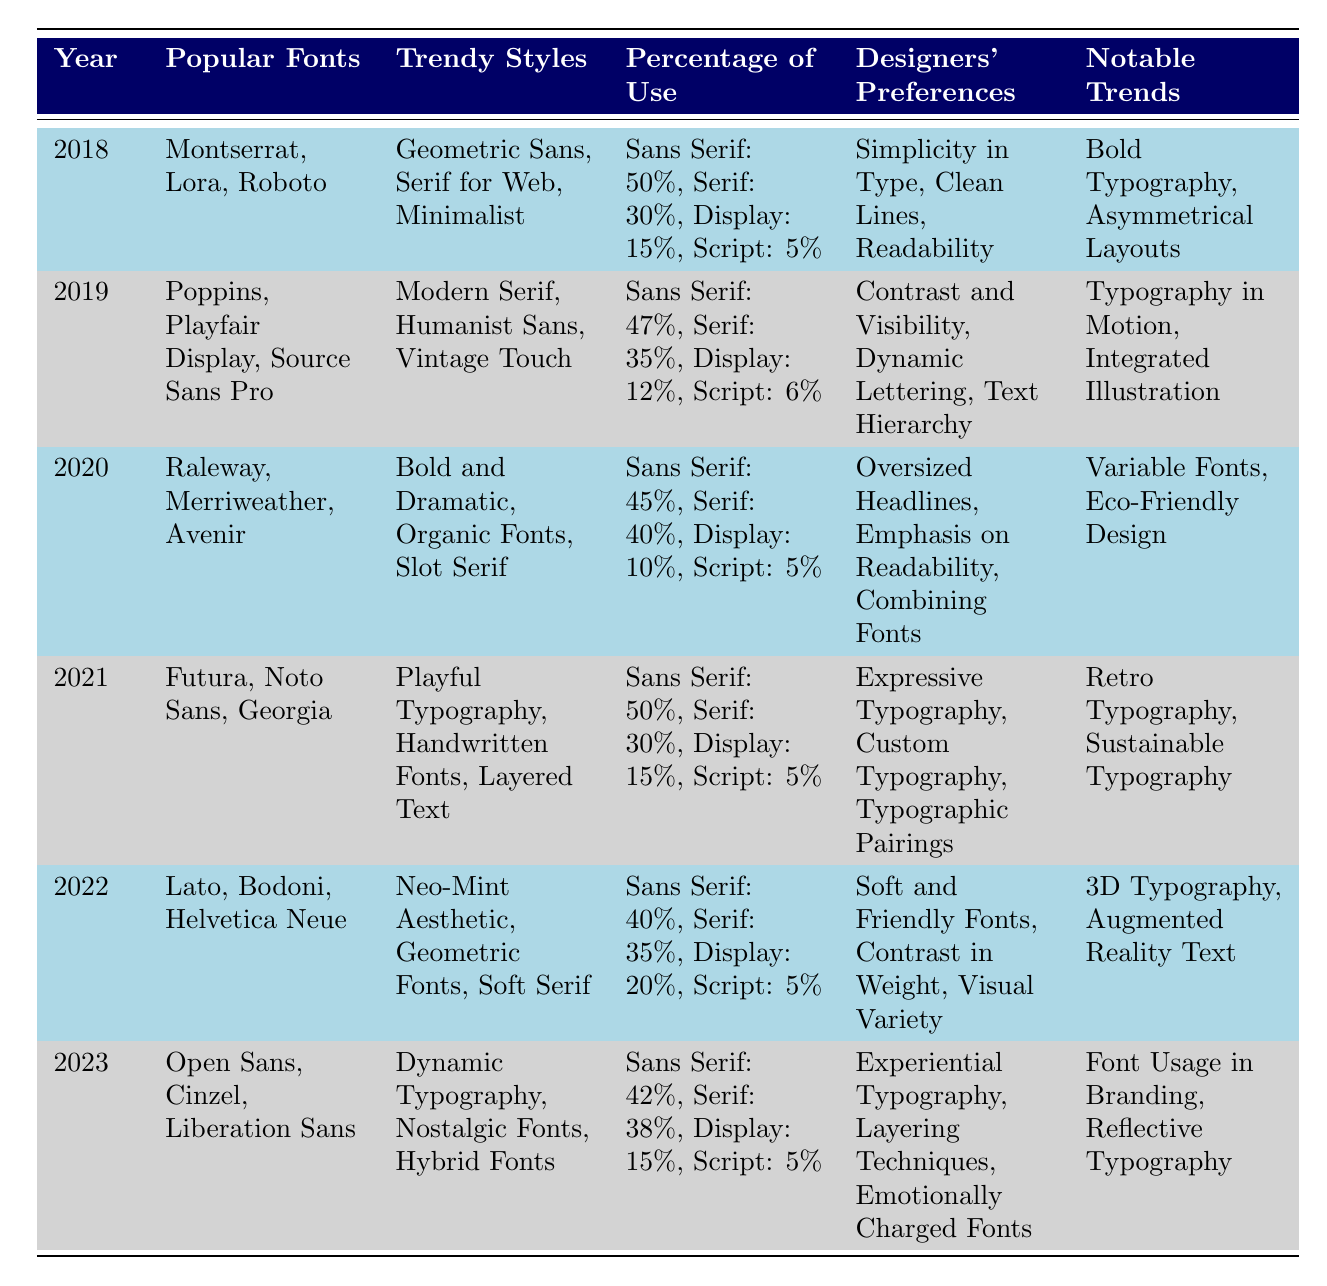What were the most popular fonts in 2021? In 2021, the popular fonts listed are Futura, Noto Sans, and Georgia.
Answer: Futura, Noto Sans, Georgia Which year had the highest percentage of Sans Serif font usage? In 2018, the percentage of use for Sans Serif fonts was 50%, which is the highest compared to other years.
Answer: 2018 What percentage of use did Display fonts have in 2022? In 2022, Display fonts had a usage percentage of 20%.
Answer: 20% Did the percentage of use for Serif fonts increase or decrease from 2019 to 2020? In 2019, the percentage of use for Serif fonts was 35%, while in 2020 it increased to 40%. Therefore, it increased.
Answer: Increased What was the notable trend for typography in motion? The notable trend for typography in motion was observed in 2019.
Answer: 2019 How many different trendy styles were noted in 2020? The table lists three trendy styles for 2020: Bold and Dramatic, Organic Fonts, and Slot Serif.
Answer: Three In which year did 'Experiential Typography' become a designer preference? 'Experiential Typography' was noted as a designer preference in 2023.
Answer: 2023 What is the average percentage of use for Script fonts across all years? The percentages for Script fonts are: 5% (2018), 6% (2019), 5% (2020), 5% (2021), 5% (2022), and 5% (2023). The average is calculated as (5 + 6 + 5 + 5 + 5 + 5) / 6 = 5.33%.
Answer: 5.33% Which years had a usage percentage for Serif fonts above 35%? The years with a percentage of use for Serif fonts above 35% are 2019 (35%) and 2020 (40%). However, only 2020 exceeds it.
Answer: 2020 What was the notable trend that emphasized sustainable typography? The notable trend that emphasized sustainable typography was noted in 2021.
Answer: 2021 